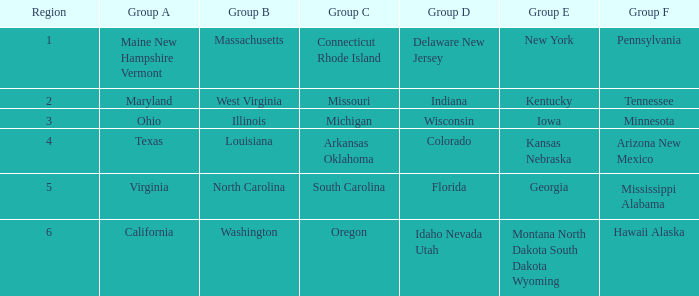What is the group A region with a region number of 2? Maryland. 